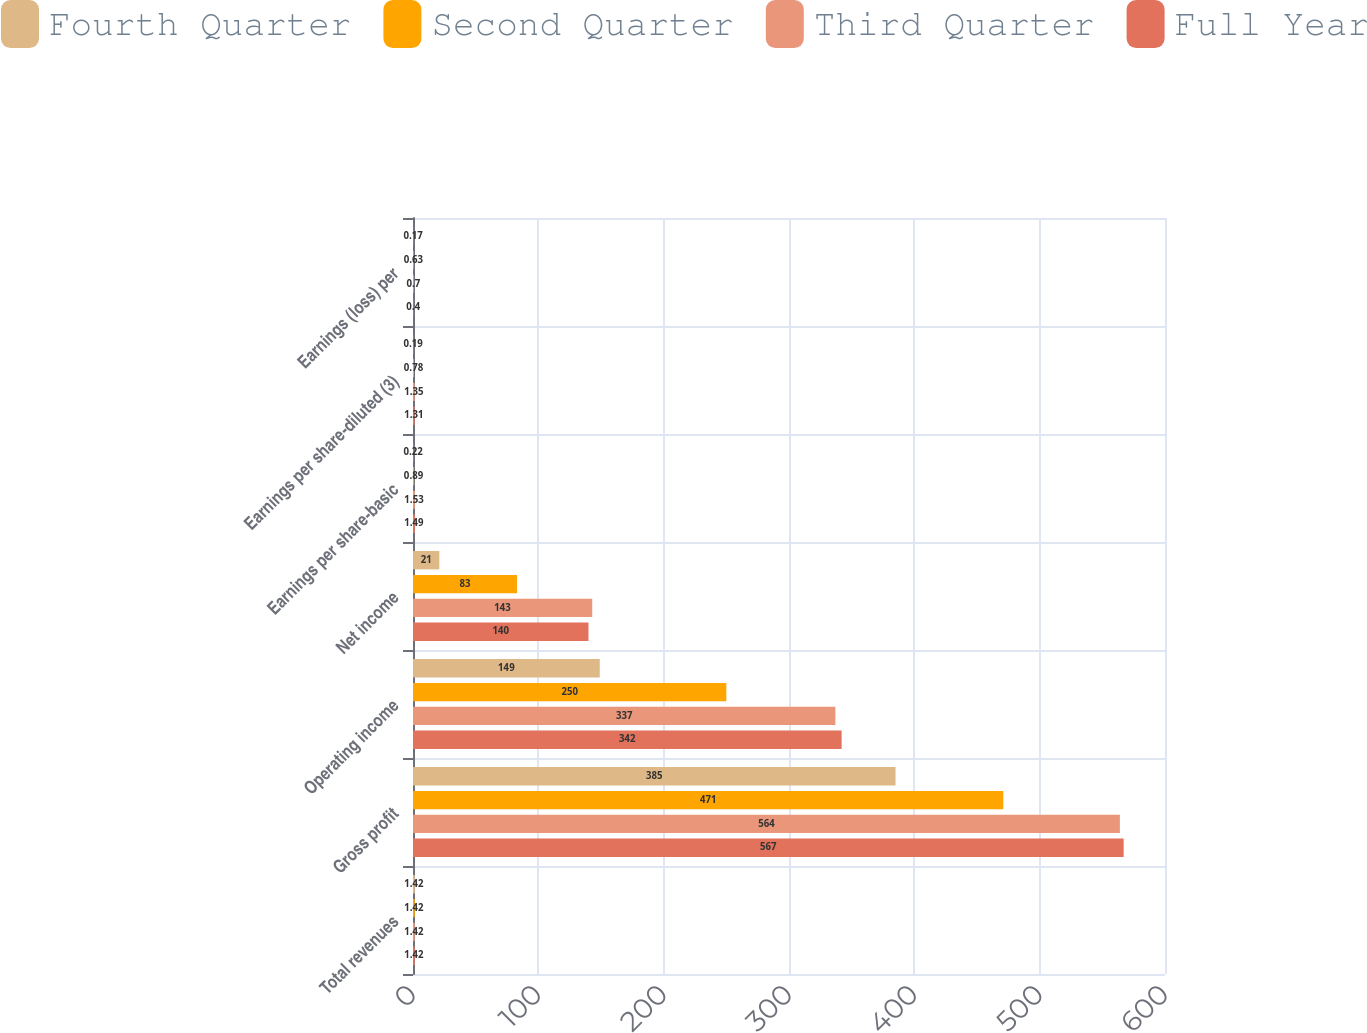<chart> <loc_0><loc_0><loc_500><loc_500><stacked_bar_chart><ecel><fcel>Total revenues<fcel>Gross profit<fcel>Operating income<fcel>Net income<fcel>Earnings per share-basic<fcel>Earnings per share-diluted (3)<fcel>Earnings (loss) per<nl><fcel>Fourth Quarter<fcel>1.42<fcel>385<fcel>149<fcel>21<fcel>0.22<fcel>0.19<fcel>0.17<nl><fcel>Second Quarter<fcel>1.42<fcel>471<fcel>250<fcel>83<fcel>0.89<fcel>0.78<fcel>0.63<nl><fcel>Third Quarter<fcel>1.42<fcel>564<fcel>337<fcel>143<fcel>1.53<fcel>1.35<fcel>0.7<nl><fcel>Full Year<fcel>1.42<fcel>567<fcel>342<fcel>140<fcel>1.49<fcel>1.31<fcel>0.4<nl></chart> 